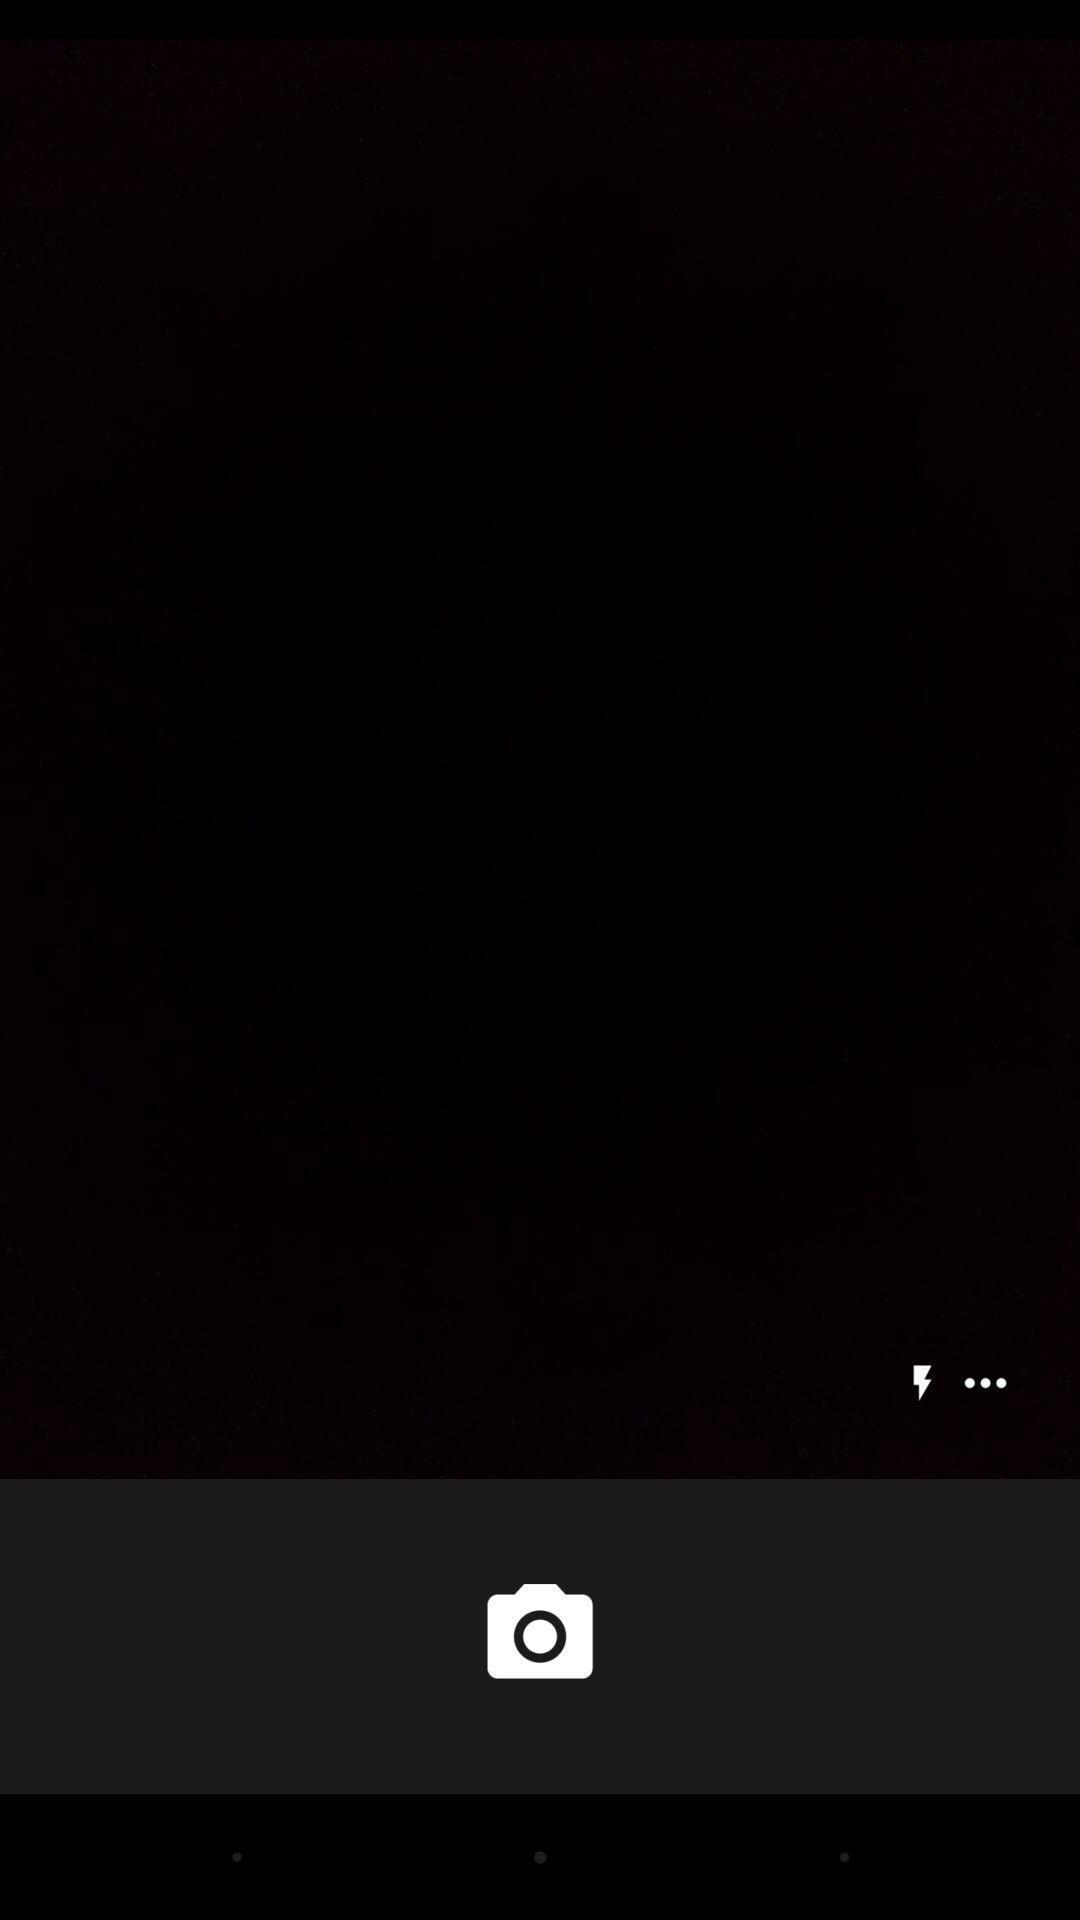Tell me about the visual elements in this screen capture. Screen displaying about camera icon. 